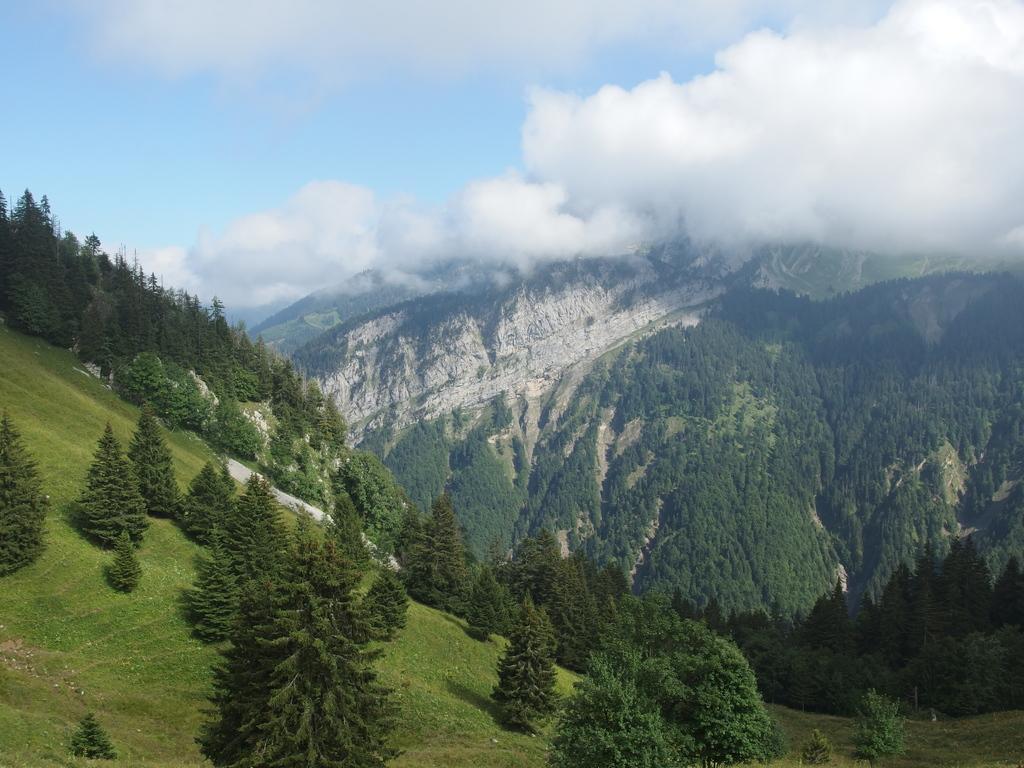How would you summarize this image in a sentence or two? In this image I can see few green trees,mountains. The sky is blue and white color. 